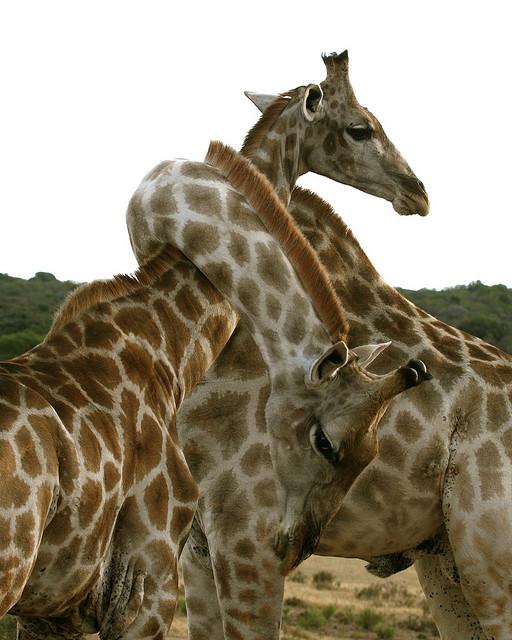What is the giraffe doing with it's neck?
Concise answer only. Hugging. Where might this picture have been taken?
Write a very short answer. Zoo. Which giraffe is taller?
Quick response, please. Right. Are the giraffes entangled?
Be succinct. Yes. Are the giraffes facing each other?
Keep it brief. No. 